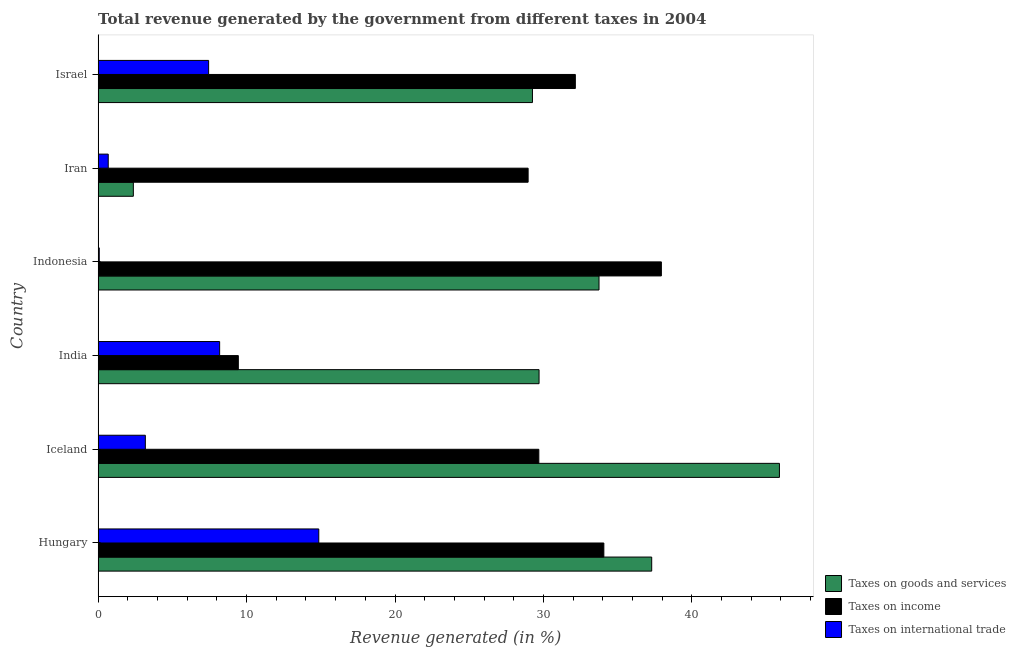How many groups of bars are there?
Your answer should be compact. 6. Are the number of bars per tick equal to the number of legend labels?
Give a very brief answer. Yes. Are the number of bars on each tick of the Y-axis equal?
Your response must be concise. Yes. How many bars are there on the 3rd tick from the top?
Provide a succinct answer. 3. How many bars are there on the 6th tick from the bottom?
Offer a terse response. 3. What is the percentage of revenue generated by taxes on income in Indonesia?
Give a very brief answer. 37.94. Across all countries, what is the maximum percentage of revenue generated by tax on international trade?
Make the answer very short. 14.86. Across all countries, what is the minimum percentage of revenue generated by taxes on income?
Offer a terse response. 9.45. In which country was the percentage of revenue generated by tax on international trade maximum?
Your response must be concise. Hungary. In which country was the percentage of revenue generated by taxes on goods and services minimum?
Offer a terse response. Iran. What is the total percentage of revenue generated by taxes on goods and services in the graph?
Provide a short and direct response. 178.26. What is the difference between the percentage of revenue generated by taxes on income in India and that in Indonesia?
Give a very brief answer. -28.5. What is the difference between the percentage of revenue generated by taxes on income in Iceland and the percentage of revenue generated by tax on international trade in India?
Provide a succinct answer. 21.5. What is the average percentage of revenue generated by tax on international trade per country?
Offer a very short reply. 5.74. What is the difference between the percentage of revenue generated by taxes on goods and services and percentage of revenue generated by tax on international trade in Hungary?
Provide a short and direct response. 22.43. What is the ratio of the percentage of revenue generated by tax on international trade in Hungary to that in India?
Keep it short and to the point. 1.82. Is the percentage of revenue generated by taxes on goods and services in Hungary less than that in Iceland?
Offer a terse response. Yes. Is the difference between the percentage of revenue generated by tax on international trade in Indonesia and Iran greater than the difference between the percentage of revenue generated by taxes on income in Indonesia and Iran?
Offer a terse response. No. What is the difference between the highest and the second highest percentage of revenue generated by taxes on goods and services?
Offer a terse response. 8.61. What is the difference between the highest and the lowest percentage of revenue generated by tax on international trade?
Keep it short and to the point. 14.79. In how many countries, is the percentage of revenue generated by tax on international trade greater than the average percentage of revenue generated by tax on international trade taken over all countries?
Your answer should be compact. 3. What does the 1st bar from the top in Iran represents?
Ensure brevity in your answer.  Taxes on international trade. What does the 3rd bar from the bottom in Iceland represents?
Ensure brevity in your answer.  Taxes on international trade. Is it the case that in every country, the sum of the percentage of revenue generated by taxes on goods and services and percentage of revenue generated by taxes on income is greater than the percentage of revenue generated by tax on international trade?
Keep it short and to the point. Yes. How many bars are there?
Your answer should be compact. 18. What is the difference between two consecutive major ticks on the X-axis?
Offer a very short reply. 10. Does the graph contain any zero values?
Provide a short and direct response. No. How many legend labels are there?
Give a very brief answer. 3. What is the title of the graph?
Ensure brevity in your answer.  Total revenue generated by the government from different taxes in 2004. Does "Errors" appear as one of the legend labels in the graph?
Offer a terse response. No. What is the label or title of the X-axis?
Keep it short and to the point. Revenue generated (in %). What is the Revenue generated (in %) in Taxes on goods and services in Hungary?
Keep it short and to the point. 37.29. What is the Revenue generated (in %) in Taxes on income in Hungary?
Make the answer very short. 34.07. What is the Revenue generated (in %) in Taxes on international trade in Hungary?
Provide a short and direct response. 14.86. What is the Revenue generated (in %) of Taxes on goods and services in Iceland?
Your response must be concise. 45.9. What is the Revenue generated (in %) of Taxes on income in Iceland?
Your answer should be very brief. 29.69. What is the Revenue generated (in %) in Taxes on international trade in Iceland?
Provide a short and direct response. 3.18. What is the Revenue generated (in %) of Taxes on goods and services in India?
Make the answer very short. 29.7. What is the Revenue generated (in %) of Taxes on income in India?
Your answer should be compact. 9.45. What is the Revenue generated (in %) of Taxes on international trade in India?
Ensure brevity in your answer.  8.19. What is the Revenue generated (in %) in Taxes on goods and services in Indonesia?
Give a very brief answer. 33.74. What is the Revenue generated (in %) of Taxes on income in Indonesia?
Your answer should be very brief. 37.94. What is the Revenue generated (in %) in Taxes on international trade in Indonesia?
Provide a succinct answer. 0.08. What is the Revenue generated (in %) of Taxes on goods and services in Iran?
Offer a terse response. 2.37. What is the Revenue generated (in %) of Taxes on income in Iran?
Offer a very short reply. 28.97. What is the Revenue generated (in %) of Taxes on international trade in Iran?
Keep it short and to the point. 0.68. What is the Revenue generated (in %) of Taxes on goods and services in Israel?
Make the answer very short. 29.26. What is the Revenue generated (in %) of Taxes on income in Israel?
Make the answer very short. 32.15. What is the Revenue generated (in %) in Taxes on international trade in Israel?
Provide a short and direct response. 7.44. Across all countries, what is the maximum Revenue generated (in %) in Taxes on goods and services?
Ensure brevity in your answer.  45.9. Across all countries, what is the maximum Revenue generated (in %) in Taxes on income?
Ensure brevity in your answer.  37.94. Across all countries, what is the maximum Revenue generated (in %) in Taxes on international trade?
Your answer should be very brief. 14.86. Across all countries, what is the minimum Revenue generated (in %) of Taxes on goods and services?
Make the answer very short. 2.37. Across all countries, what is the minimum Revenue generated (in %) in Taxes on income?
Your answer should be very brief. 9.45. Across all countries, what is the minimum Revenue generated (in %) in Taxes on international trade?
Provide a succinct answer. 0.08. What is the total Revenue generated (in %) of Taxes on goods and services in the graph?
Keep it short and to the point. 178.26. What is the total Revenue generated (in %) in Taxes on income in the graph?
Offer a terse response. 172.26. What is the total Revenue generated (in %) in Taxes on international trade in the graph?
Ensure brevity in your answer.  34.44. What is the difference between the Revenue generated (in %) of Taxes on goods and services in Hungary and that in Iceland?
Make the answer very short. -8.61. What is the difference between the Revenue generated (in %) in Taxes on income in Hungary and that in Iceland?
Ensure brevity in your answer.  4.38. What is the difference between the Revenue generated (in %) in Taxes on international trade in Hungary and that in Iceland?
Provide a short and direct response. 11.68. What is the difference between the Revenue generated (in %) of Taxes on goods and services in Hungary and that in India?
Provide a short and direct response. 7.59. What is the difference between the Revenue generated (in %) in Taxes on income in Hungary and that in India?
Your answer should be very brief. 24.62. What is the difference between the Revenue generated (in %) of Taxes on international trade in Hungary and that in India?
Make the answer very short. 6.68. What is the difference between the Revenue generated (in %) of Taxes on goods and services in Hungary and that in Indonesia?
Provide a short and direct response. 3.55. What is the difference between the Revenue generated (in %) of Taxes on income in Hungary and that in Indonesia?
Make the answer very short. -3.88. What is the difference between the Revenue generated (in %) of Taxes on international trade in Hungary and that in Indonesia?
Provide a short and direct response. 14.79. What is the difference between the Revenue generated (in %) in Taxes on goods and services in Hungary and that in Iran?
Ensure brevity in your answer.  34.92. What is the difference between the Revenue generated (in %) of Taxes on income in Hungary and that in Iran?
Provide a short and direct response. 5.1. What is the difference between the Revenue generated (in %) in Taxes on international trade in Hungary and that in Iran?
Make the answer very short. 14.18. What is the difference between the Revenue generated (in %) in Taxes on goods and services in Hungary and that in Israel?
Make the answer very short. 8.03. What is the difference between the Revenue generated (in %) of Taxes on income in Hungary and that in Israel?
Keep it short and to the point. 1.92. What is the difference between the Revenue generated (in %) of Taxes on international trade in Hungary and that in Israel?
Your answer should be compact. 7.42. What is the difference between the Revenue generated (in %) in Taxes on goods and services in Iceland and that in India?
Offer a very short reply. 16.19. What is the difference between the Revenue generated (in %) in Taxes on income in Iceland and that in India?
Ensure brevity in your answer.  20.24. What is the difference between the Revenue generated (in %) of Taxes on international trade in Iceland and that in India?
Provide a short and direct response. -5.01. What is the difference between the Revenue generated (in %) of Taxes on goods and services in Iceland and that in Indonesia?
Your answer should be very brief. 12.15. What is the difference between the Revenue generated (in %) of Taxes on income in Iceland and that in Indonesia?
Your answer should be compact. -8.26. What is the difference between the Revenue generated (in %) of Taxes on international trade in Iceland and that in Indonesia?
Keep it short and to the point. 3.1. What is the difference between the Revenue generated (in %) of Taxes on goods and services in Iceland and that in Iran?
Provide a succinct answer. 43.52. What is the difference between the Revenue generated (in %) in Taxes on income in Iceland and that in Iran?
Your answer should be compact. 0.72. What is the difference between the Revenue generated (in %) of Taxes on international trade in Iceland and that in Iran?
Keep it short and to the point. 2.5. What is the difference between the Revenue generated (in %) of Taxes on goods and services in Iceland and that in Israel?
Make the answer very short. 16.64. What is the difference between the Revenue generated (in %) of Taxes on income in Iceland and that in Israel?
Give a very brief answer. -2.46. What is the difference between the Revenue generated (in %) of Taxes on international trade in Iceland and that in Israel?
Ensure brevity in your answer.  -4.26. What is the difference between the Revenue generated (in %) in Taxes on goods and services in India and that in Indonesia?
Offer a very short reply. -4.04. What is the difference between the Revenue generated (in %) of Taxes on income in India and that in Indonesia?
Your response must be concise. -28.5. What is the difference between the Revenue generated (in %) of Taxes on international trade in India and that in Indonesia?
Your response must be concise. 8.11. What is the difference between the Revenue generated (in %) of Taxes on goods and services in India and that in Iran?
Give a very brief answer. 27.33. What is the difference between the Revenue generated (in %) in Taxes on income in India and that in Iran?
Make the answer very short. -19.52. What is the difference between the Revenue generated (in %) of Taxes on international trade in India and that in Iran?
Keep it short and to the point. 7.5. What is the difference between the Revenue generated (in %) of Taxes on goods and services in India and that in Israel?
Give a very brief answer. 0.44. What is the difference between the Revenue generated (in %) in Taxes on income in India and that in Israel?
Offer a terse response. -22.7. What is the difference between the Revenue generated (in %) in Taxes on international trade in India and that in Israel?
Provide a succinct answer. 0.74. What is the difference between the Revenue generated (in %) of Taxes on goods and services in Indonesia and that in Iran?
Your answer should be very brief. 31.37. What is the difference between the Revenue generated (in %) in Taxes on income in Indonesia and that in Iran?
Your answer should be very brief. 8.98. What is the difference between the Revenue generated (in %) in Taxes on international trade in Indonesia and that in Iran?
Your answer should be very brief. -0.6. What is the difference between the Revenue generated (in %) in Taxes on goods and services in Indonesia and that in Israel?
Provide a short and direct response. 4.48. What is the difference between the Revenue generated (in %) in Taxes on income in Indonesia and that in Israel?
Provide a succinct answer. 5.8. What is the difference between the Revenue generated (in %) of Taxes on international trade in Indonesia and that in Israel?
Ensure brevity in your answer.  -7.37. What is the difference between the Revenue generated (in %) of Taxes on goods and services in Iran and that in Israel?
Make the answer very short. -26.89. What is the difference between the Revenue generated (in %) in Taxes on income in Iran and that in Israel?
Your response must be concise. -3.18. What is the difference between the Revenue generated (in %) in Taxes on international trade in Iran and that in Israel?
Your response must be concise. -6.76. What is the difference between the Revenue generated (in %) in Taxes on goods and services in Hungary and the Revenue generated (in %) in Taxes on income in Iceland?
Provide a short and direct response. 7.6. What is the difference between the Revenue generated (in %) of Taxes on goods and services in Hungary and the Revenue generated (in %) of Taxes on international trade in Iceland?
Offer a terse response. 34.11. What is the difference between the Revenue generated (in %) in Taxes on income in Hungary and the Revenue generated (in %) in Taxes on international trade in Iceland?
Keep it short and to the point. 30.89. What is the difference between the Revenue generated (in %) of Taxes on goods and services in Hungary and the Revenue generated (in %) of Taxes on income in India?
Your answer should be compact. 27.85. What is the difference between the Revenue generated (in %) of Taxes on goods and services in Hungary and the Revenue generated (in %) of Taxes on international trade in India?
Give a very brief answer. 29.1. What is the difference between the Revenue generated (in %) of Taxes on income in Hungary and the Revenue generated (in %) of Taxes on international trade in India?
Keep it short and to the point. 25.88. What is the difference between the Revenue generated (in %) of Taxes on goods and services in Hungary and the Revenue generated (in %) of Taxes on income in Indonesia?
Make the answer very short. -0.65. What is the difference between the Revenue generated (in %) of Taxes on goods and services in Hungary and the Revenue generated (in %) of Taxes on international trade in Indonesia?
Make the answer very short. 37.21. What is the difference between the Revenue generated (in %) of Taxes on income in Hungary and the Revenue generated (in %) of Taxes on international trade in Indonesia?
Keep it short and to the point. 33.99. What is the difference between the Revenue generated (in %) in Taxes on goods and services in Hungary and the Revenue generated (in %) in Taxes on income in Iran?
Offer a very short reply. 8.32. What is the difference between the Revenue generated (in %) of Taxes on goods and services in Hungary and the Revenue generated (in %) of Taxes on international trade in Iran?
Offer a terse response. 36.61. What is the difference between the Revenue generated (in %) in Taxes on income in Hungary and the Revenue generated (in %) in Taxes on international trade in Iran?
Keep it short and to the point. 33.39. What is the difference between the Revenue generated (in %) of Taxes on goods and services in Hungary and the Revenue generated (in %) of Taxes on income in Israel?
Your answer should be compact. 5.14. What is the difference between the Revenue generated (in %) in Taxes on goods and services in Hungary and the Revenue generated (in %) in Taxes on international trade in Israel?
Offer a terse response. 29.85. What is the difference between the Revenue generated (in %) of Taxes on income in Hungary and the Revenue generated (in %) of Taxes on international trade in Israel?
Give a very brief answer. 26.62. What is the difference between the Revenue generated (in %) in Taxes on goods and services in Iceland and the Revenue generated (in %) in Taxes on income in India?
Provide a succinct answer. 36.45. What is the difference between the Revenue generated (in %) in Taxes on goods and services in Iceland and the Revenue generated (in %) in Taxes on international trade in India?
Keep it short and to the point. 37.71. What is the difference between the Revenue generated (in %) of Taxes on income in Iceland and the Revenue generated (in %) of Taxes on international trade in India?
Provide a short and direct response. 21.5. What is the difference between the Revenue generated (in %) in Taxes on goods and services in Iceland and the Revenue generated (in %) in Taxes on income in Indonesia?
Your answer should be compact. 7.95. What is the difference between the Revenue generated (in %) in Taxes on goods and services in Iceland and the Revenue generated (in %) in Taxes on international trade in Indonesia?
Your answer should be very brief. 45.82. What is the difference between the Revenue generated (in %) of Taxes on income in Iceland and the Revenue generated (in %) of Taxes on international trade in Indonesia?
Make the answer very short. 29.61. What is the difference between the Revenue generated (in %) in Taxes on goods and services in Iceland and the Revenue generated (in %) in Taxes on income in Iran?
Give a very brief answer. 16.93. What is the difference between the Revenue generated (in %) in Taxes on goods and services in Iceland and the Revenue generated (in %) in Taxes on international trade in Iran?
Give a very brief answer. 45.21. What is the difference between the Revenue generated (in %) of Taxes on income in Iceland and the Revenue generated (in %) of Taxes on international trade in Iran?
Provide a succinct answer. 29. What is the difference between the Revenue generated (in %) of Taxes on goods and services in Iceland and the Revenue generated (in %) of Taxes on income in Israel?
Keep it short and to the point. 13.75. What is the difference between the Revenue generated (in %) of Taxes on goods and services in Iceland and the Revenue generated (in %) of Taxes on international trade in Israel?
Offer a terse response. 38.45. What is the difference between the Revenue generated (in %) of Taxes on income in Iceland and the Revenue generated (in %) of Taxes on international trade in Israel?
Give a very brief answer. 22.24. What is the difference between the Revenue generated (in %) in Taxes on goods and services in India and the Revenue generated (in %) in Taxes on income in Indonesia?
Ensure brevity in your answer.  -8.24. What is the difference between the Revenue generated (in %) in Taxes on goods and services in India and the Revenue generated (in %) in Taxes on international trade in Indonesia?
Make the answer very short. 29.63. What is the difference between the Revenue generated (in %) in Taxes on income in India and the Revenue generated (in %) in Taxes on international trade in Indonesia?
Give a very brief answer. 9.37. What is the difference between the Revenue generated (in %) of Taxes on goods and services in India and the Revenue generated (in %) of Taxes on income in Iran?
Make the answer very short. 0.74. What is the difference between the Revenue generated (in %) of Taxes on goods and services in India and the Revenue generated (in %) of Taxes on international trade in Iran?
Offer a terse response. 29.02. What is the difference between the Revenue generated (in %) of Taxes on income in India and the Revenue generated (in %) of Taxes on international trade in Iran?
Provide a succinct answer. 8.76. What is the difference between the Revenue generated (in %) of Taxes on goods and services in India and the Revenue generated (in %) of Taxes on income in Israel?
Your response must be concise. -2.44. What is the difference between the Revenue generated (in %) in Taxes on goods and services in India and the Revenue generated (in %) in Taxes on international trade in Israel?
Keep it short and to the point. 22.26. What is the difference between the Revenue generated (in %) in Taxes on income in India and the Revenue generated (in %) in Taxes on international trade in Israel?
Your response must be concise. 2. What is the difference between the Revenue generated (in %) of Taxes on goods and services in Indonesia and the Revenue generated (in %) of Taxes on income in Iran?
Your answer should be very brief. 4.78. What is the difference between the Revenue generated (in %) of Taxes on goods and services in Indonesia and the Revenue generated (in %) of Taxes on international trade in Iran?
Your answer should be compact. 33.06. What is the difference between the Revenue generated (in %) in Taxes on income in Indonesia and the Revenue generated (in %) in Taxes on international trade in Iran?
Provide a short and direct response. 37.26. What is the difference between the Revenue generated (in %) in Taxes on goods and services in Indonesia and the Revenue generated (in %) in Taxes on income in Israel?
Provide a short and direct response. 1.59. What is the difference between the Revenue generated (in %) of Taxes on goods and services in Indonesia and the Revenue generated (in %) of Taxes on international trade in Israel?
Your answer should be compact. 26.3. What is the difference between the Revenue generated (in %) in Taxes on income in Indonesia and the Revenue generated (in %) in Taxes on international trade in Israel?
Make the answer very short. 30.5. What is the difference between the Revenue generated (in %) of Taxes on goods and services in Iran and the Revenue generated (in %) of Taxes on income in Israel?
Provide a short and direct response. -29.77. What is the difference between the Revenue generated (in %) of Taxes on goods and services in Iran and the Revenue generated (in %) of Taxes on international trade in Israel?
Offer a very short reply. -5.07. What is the difference between the Revenue generated (in %) in Taxes on income in Iran and the Revenue generated (in %) in Taxes on international trade in Israel?
Your response must be concise. 21.52. What is the average Revenue generated (in %) in Taxes on goods and services per country?
Offer a terse response. 29.71. What is the average Revenue generated (in %) in Taxes on income per country?
Provide a short and direct response. 28.71. What is the average Revenue generated (in %) of Taxes on international trade per country?
Your response must be concise. 5.74. What is the difference between the Revenue generated (in %) in Taxes on goods and services and Revenue generated (in %) in Taxes on income in Hungary?
Your answer should be compact. 3.22. What is the difference between the Revenue generated (in %) of Taxes on goods and services and Revenue generated (in %) of Taxes on international trade in Hungary?
Ensure brevity in your answer.  22.43. What is the difference between the Revenue generated (in %) of Taxes on income and Revenue generated (in %) of Taxes on international trade in Hungary?
Keep it short and to the point. 19.2. What is the difference between the Revenue generated (in %) of Taxes on goods and services and Revenue generated (in %) of Taxes on income in Iceland?
Provide a succinct answer. 16.21. What is the difference between the Revenue generated (in %) in Taxes on goods and services and Revenue generated (in %) in Taxes on international trade in Iceland?
Your response must be concise. 42.72. What is the difference between the Revenue generated (in %) in Taxes on income and Revenue generated (in %) in Taxes on international trade in Iceland?
Provide a short and direct response. 26.51. What is the difference between the Revenue generated (in %) of Taxes on goods and services and Revenue generated (in %) of Taxes on income in India?
Ensure brevity in your answer.  20.26. What is the difference between the Revenue generated (in %) in Taxes on goods and services and Revenue generated (in %) in Taxes on international trade in India?
Your response must be concise. 21.52. What is the difference between the Revenue generated (in %) in Taxes on income and Revenue generated (in %) in Taxes on international trade in India?
Provide a succinct answer. 1.26. What is the difference between the Revenue generated (in %) of Taxes on goods and services and Revenue generated (in %) of Taxes on income in Indonesia?
Your answer should be compact. -4.2. What is the difference between the Revenue generated (in %) in Taxes on goods and services and Revenue generated (in %) in Taxes on international trade in Indonesia?
Offer a terse response. 33.66. What is the difference between the Revenue generated (in %) in Taxes on income and Revenue generated (in %) in Taxes on international trade in Indonesia?
Give a very brief answer. 37.87. What is the difference between the Revenue generated (in %) of Taxes on goods and services and Revenue generated (in %) of Taxes on income in Iran?
Make the answer very short. -26.59. What is the difference between the Revenue generated (in %) in Taxes on goods and services and Revenue generated (in %) in Taxes on international trade in Iran?
Your response must be concise. 1.69. What is the difference between the Revenue generated (in %) in Taxes on income and Revenue generated (in %) in Taxes on international trade in Iran?
Your answer should be very brief. 28.28. What is the difference between the Revenue generated (in %) of Taxes on goods and services and Revenue generated (in %) of Taxes on income in Israel?
Provide a succinct answer. -2.89. What is the difference between the Revenue generated (in %) of Taxes on goods and services and Revenue generated (in %) of Taxes on international trade in Israel?
Your answer should be compact. 21.81. What is the difference between the Revenue generated (in %) in Taxes on income and Revenue generated (in %) in Taxes on international trade in Israel?
Provide a short and direct response. 24.7. What is the ratio of the Revenue generated (in %) in Taxes on goods and services in Hungary to that in Iceland?
Offer a very short reply. 0.81. What is the ratio of the Revenue generated (in %) in Taxes on income in Hungary to that in Iceland?
Provide a short and direct response. 1.15. What is the ratio of the Revenue generated (in %) in Taxes on international trade in Hungary to that in Iceland?
Offer a terse response. 4.67. What is the ratio of the Revenue generated (in %) of Taxes on goods and services in Hungary to that in India?
Make the answer very short. 1.26. What is the ratio of the Revenue generated (in %) of Taxes on income in Hungary to that in India?
Make the answer very short. 3.61. What is the ratio of the Revenue generated (in %) in Taxes on international trade in Hungary to that in India?
Provide a succinct answer. 1.82. What is the ratio of the Revenue generated (in %) in Taxes on goods and services in Hungary to that in Indonesia?
Your response must be concise. 1.11. What is the ratio of the Revenue generated (in %) in Taxes on income in Hungary to that in Indonesia?
Ensure brevity in your answer.  0.9. What is the ratio of the Revenue generated (in %) of Taxes on international trade in Hungary to that in Indonesia?
Provide a succinct answer. 191.38. What is the ratio of the Revenue generated (in %) in Taxes on goods and services in Hungary to that in Iran?
Make the answer very short. 15.72. What is the ratio of the Revenue generated (in %) in Taxes on income in Hungary to that in Iran?
Provide a succinct answer. 1.18. What is the ratio of the Revenue generated (in %) of Taxes on international trade in Hungary to that in Iran?
Ensure brevity in your answer.  21.8. What is the ratio of the Revenue generated (in %) in Taxes on goods and services in Hungary to that in Israel?
Give a very brief answer. 1.27. What is the ratio of the Revenue generated (in %) of Taxes on income in Hungary to that in Israel?
Make the answer very short. 1.06. What is the ratio of the Revenue generated (in %) in Taxes on international trade in Hungary to that in Israel?
Your response must be concise. 2. What is the ratio of the Revenue generated (in %) of Taxes on goods and services in Iceland to that in India?
Provide a succinct answer. 1.55. What is the ratio of the Revenue generated (in %) in Taxes on income in Iceland to that in India?
Make the answer very short. 3.14. What is the ratio of the Revenue generated (in %) of Taxes on international trade in Iceland to that in India?
Make the answer very short. 0.39. What is the ratio of the Revenue generated (in %) in Taxes on goods and services in Iceland to that in Indonesia?
Offer a very short reply. 1.36. What is the ratio of the Revenue generated (in %) in Taxes on income in Iceland to that in Indonesia?
Your answer should be very brief. 0.78. What is the ratio of the Revenue generated (in %) of Taxes on international trade in Iceland to that in Indonesia?
Offer a terse response. 40.95. What is the ratio of the Revenue generated (in %) of Taxes on goods and services in Iceland to that in Iran?
Offer a very short reply. 19.34. What is the ratio of the Revenue generated (in %) of Taxes on income in Iceland to that in Iran?
Offer a very short reply. 1.02. What is the ratio of the Revenue generated (in %) in Taxes on international trade in Iceland to that in Iran?
Your answer should be very brief. 4.66. What is the ratio of the Revenue generated (in %) of Taxes on goods and services in Iceland to that in Israel?
Keep it short and to the point. 1.57. What is the ratio of the Revenue generated (in %) in Taxes on income in Iceland to that in Israel?
Provide a succinct answer. 0.92. What is the ratio of the Revenue generated (in %) of Taxes on international trade in Iceland to that in Israel?
Keep it short and to the point. 0.43. What is the ratio of the Revenue generated (in %) of Taxes on goods and services in India to that in Indonesia?
Your answer should be compact. 0.88. What is the ratio of the Revenue generated (in %) in Taxes on income in India to that in Indonesia?
Your response must be concise. 0.25. What is the ratio of the Revenue generated (in %) of Taxes on international trade in India to that in Indonesia?
Give a very brief answer. 105.39. What is the ratio of the Revenue generated (in %) of Taxes on goods and services in India to that in Iran?
Provide a short and direct response. 12.52. What is the ratio of the Revenue generated (in %) of Taxes on income in India to that in Iran?
Your answer should be very brief. 0.33. What is the ratio of the Revenue generated (in %) of Taxes on international trade in India to that in Iran?
Your response must be concise. 12. What is the ratio of the Revenue generated (in %) of Taxes on goods and services in India to that in Israel?
Make the answer very short. 1.02. What is the ratio of the Revenue generated (in %) of Taxes on income in India to that in Israel?
Your response must be concise. 0.29. What is the ratio of the Revenue generated (in %) of Taxes on international trade in India to that in Israel?
Give a very brief answer. 1.1. What is the ratio of the Revenue generated (in %) in Taxes on goods and services in Indonesia to that in Iran?
Keep it short and to the point. 14.22. What is the ratio of the Revenue generated (in %) of Taxes on income in Indonesia to that in Iran?
Make the answer very short. 1.31. What is the ratio of the Revenue generated (in %) in Taxes on international trade in Indonesia to that in Iran?
Keep it short and to the point. 0.11. What is the ratio of the Revenue generated (in %) of Taxes on goods and services in Indonesia to that in Israel?
Provide a short and direct response. 1.15. What is the ratio of the Revenue generated (in %) in Taxes on income in Indonesia to that in Israel?
Ensure brevity in your answer.  1.18. What is the ratio of the Revenue generated (in %) in Taxes on international trade in Indonesia to that in Israel?
Ensure brevity in your answer.  0.01. What is the ratio of the Revenue generated (in %) of Taxes on goods and services in Iran to that in Israel?
Offer a terse response. 0.08. What is the ratio of the Revenue generated (in %) of Taxes on income in Iran to that in Israel?
Ensure brevity in your answer.  0.9. What is the ratio of the Revenue generated (in %) of Taxes on international trade in Iran to that in Israel?
Your response must be concise. 0.09. What is the difference between the highest and the second highest Revenue generated (in %) in Taxes on goods and services?
Your answer should be compact. 8.61. What is the difference between the highest and the second highest Revenue generated (in %) of Taxes on income?
Your response must be concise. 3.88. What is the difference between the highest and the second highest Revenue generated (in %) of Taxes on international trade?
Provide a short and direct response. 6.68. What is the difference between the highest and the lowest Revenue generated (in %) of Taxes on goods and services?
Provide a short and direct response. 43.52. What is the difference between the highest and the lowest Revenue generated (in %) of Taxes on income?
Your response must be concise. 28.5. What is the difference between the highest and the lowest Revenue generated (in %) of Taxes on international trade?
Ensure brevity in your answer.  14.79. 